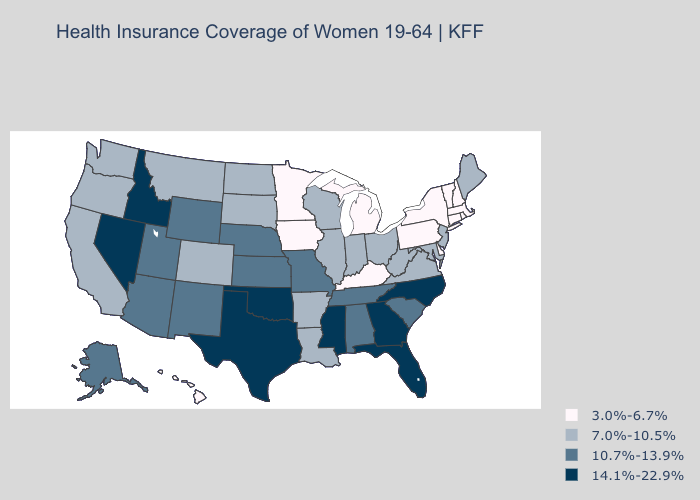Name the states that have a value in the range 14.1%-22.9%?
Concise answer only. Florida, Georgia, Idaho, Mississippi, Nevada, North Carolina, Oklahoma, Texas. What is the value of Arkansas?
Concise answer only. 7.0%-10.5%. Does Colorado have the same value as North Carolina?
Concise answer only. No. Does Georgia have the highest value in the USA?
Answer briefly. Yes. Does Texas have the same value as Mississippi?
Write a very short answer. Yes. Among the states that border Delaware , does Pennsylvania have the highest value?
Concise answer only. No. Name the states that have a value in the range 3.0%-6.7%?
Concise answer only. Connecticut, Delaware, Hawaii, Iowa, Kentucky, Massachusetts, Michigan, Minnesota, New Hampshire, New York, Pennsylvania, Rhode Island, Vermont. Does Nevada have a higher value than Kansas?
Short answer required. Yes. Among the states that border New York , does New Jersey have the highest value?
Short answer required. Yes. Name the states that have a value in the range 3.0%-6.7%?
Quick response, please. Connecticut, Delaware, Hawaii, Iowa, Kentucky, Massachusetts, Michigan, Minnesota, New Hampshire, New York, Pennsylvania, Rhode Island, Vermont. Does Wyoming have the highest value in the USA?
Short answer required. No. What is the value of Florida?
Write a very short answer. 14.1%-22.9%. Name the states that have a value in the range 14.1%-22.9%?
Quick response, please. Florida, Georgia, Idaho, Mississippi, Nevada, North Carolina, Oklahoma, Texas. Does New Mexico have the highest value in the West?
Short answer required. No. 